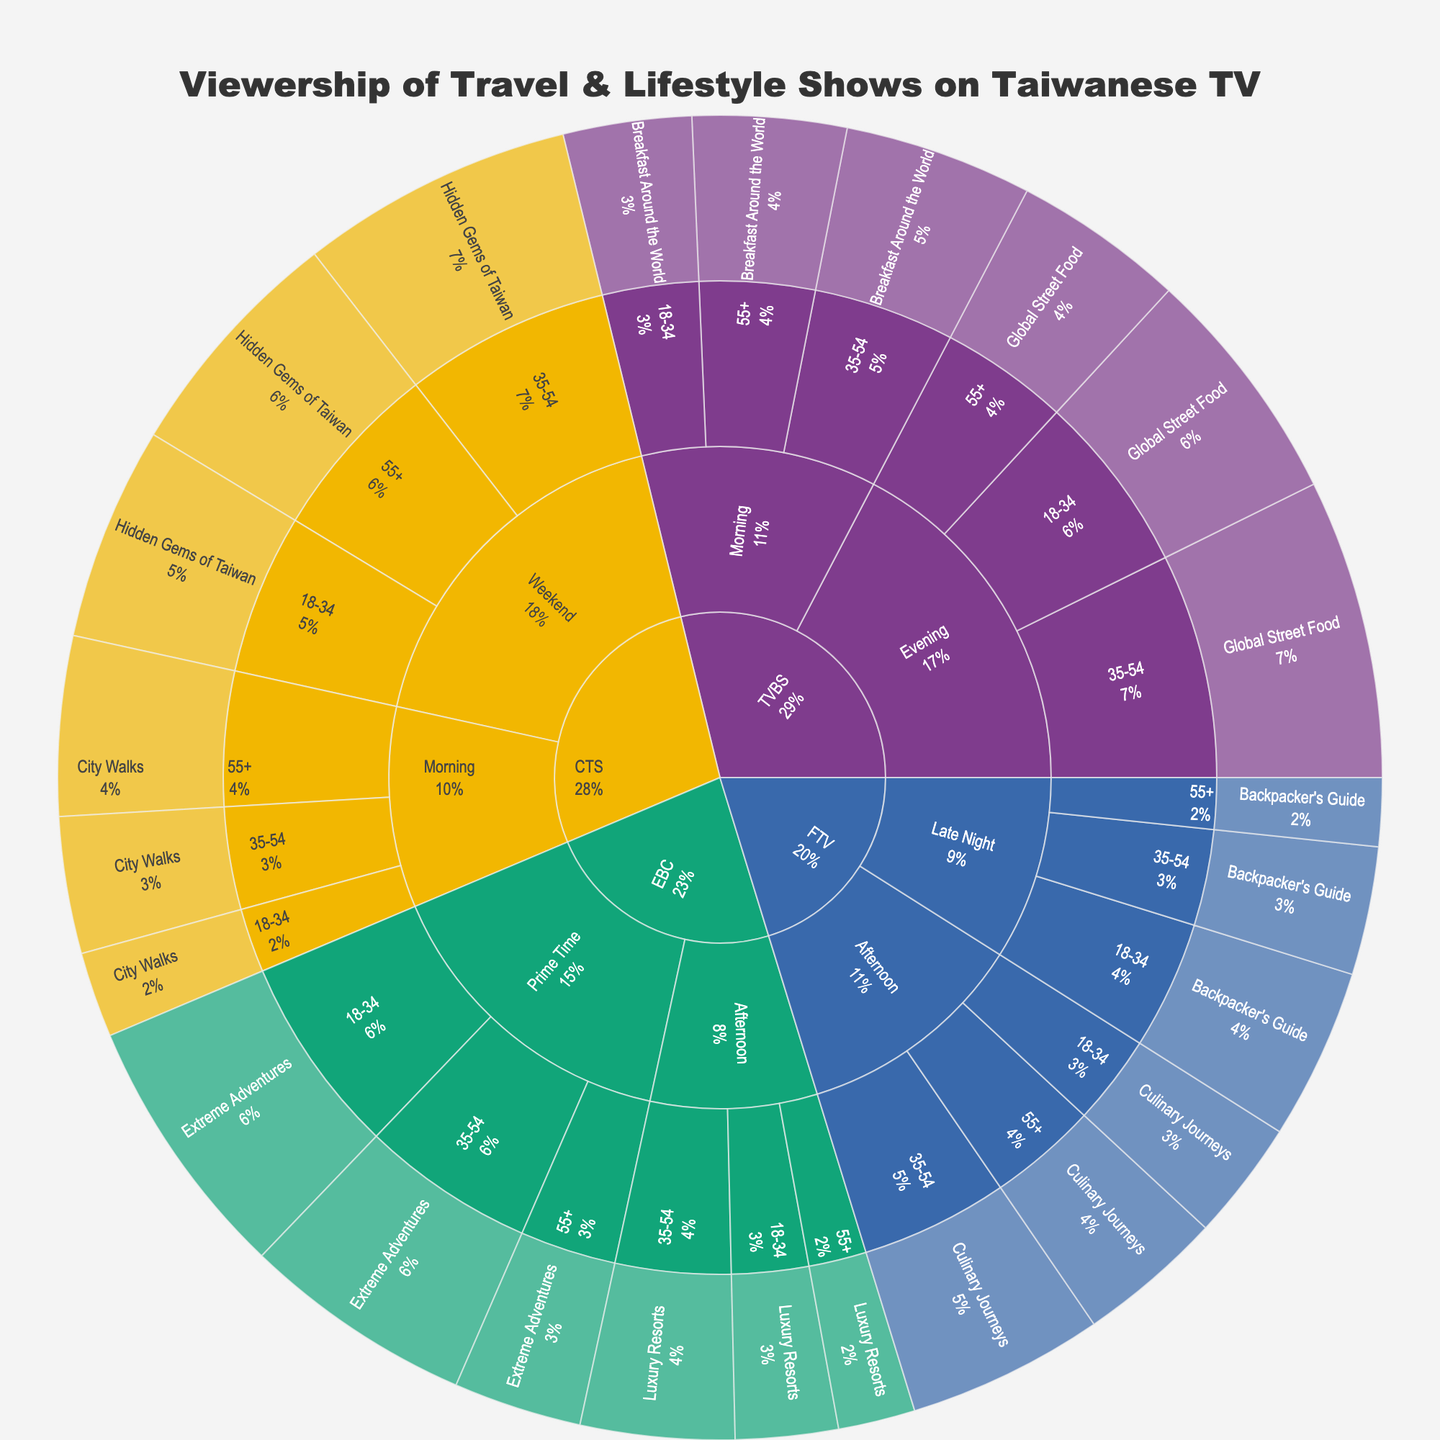what's the title of the sunburst plot? The title of the sunburst plot is located at the top center of the plot, displayed prominently. It reads: "Viewership of Travel & Lifestyle Shows on Taiwanese TV"
Answer: Viewership of Travel & Lifestyle Shows on Taiwanese TV Which show on TVBS has the highest viewership in the evening time slot? To determine the show with the highest viewership on TVBS in the evening time slot, we locate the TVBS sector, then the evening time slot, and find the largest segment. "Global Street Food" has the highest viewership for TVBS in the evening.
Answer: Global Street Food What is the total viewership for 'Luxury Resorts' across all demographics on EBC? Add the viewership numbers for each demographic for "Luxury Resorts" on EBC: 18-34 (120,000) + 35-54 (180,000) + 55+ (90,000). The sum is 120,000 + 180,000 + 90,000 = 390,000.
Answer: 390,000 Which demographic prefers 'Extreme Adventures' the most on EBC during prime time? Check each demographic within the prime time slot for "Extreme Adventures" on EBC and compare the viewership: 18-34 (310,000), 35-54 (270,000), 55+ (150,000). The 18-34 demographic has the highest viewership.
Answer: 18-34 Is the viewership of 'City Walks' higher in the morning or the viewership of 'Hidden Gems of Taiwan' during the weekend for CTS? Compare the total viewership of "City Walks" in the morning (18-34: 100,000, 35-54: 160,000, 55+: 210,000) with "Hidden Gems of Taiwan" during the weekend (18-34: 250,000, 35-54: 320,000, 55+: 280,000). The sums are 100,000 + 160,000 + 210,000 = 470,000 and 250,000 + 320,000 + 280,000 = 850,000.
Answer: Hidden Gems of Taiwan What's the average viewership for travel and lifestyle shows in the late-night time slot on FTV? The late-night shows on FTV and their viewership numbers are as follows: 18-34 (200,000), 35-54 (150,000), 55+ (80,000). Calculate the average: (200,000 + 150,000 + 80,000) / 3 = 430,000 / 3 ≈ 143,333.
Answer: 143,333 How does the viewership of 'Backpacker's Guide' change across different demographics in the late-night slot on FTV? Compare viewership across demographics for "Backpacker's Guide" in the late-night slot on FTV: 18-34 (200,000), 35-54 (150,000), 55+ (80,000). The viewership decreases from 18-34 to 35-54 and then to 55+.
Answer: Decreases In which time slot does 'Global Street Food' on TVBS have the higher viewership, morning or evening? Compare the viewership for "Global Street Food" in the evening (18-34: 280,000, 35-54: 350,000, 55+: 200,000) to the viewership of the morning slot (no data for "Global Street Food"). "Global Street Food" has no morning slot on TVBS; it's only available in the evening.
Answer: Evening 